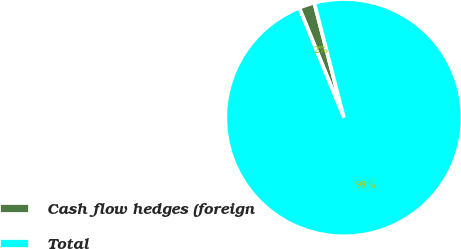Convert chart. <chart><loc_0><loc_0><loc_500><loc_500><pie_chart><fcel>Cash flow hedges (foreign<fcel>Total<nl><fcel>2.13%<fcel>97.87%<nl></chart> 